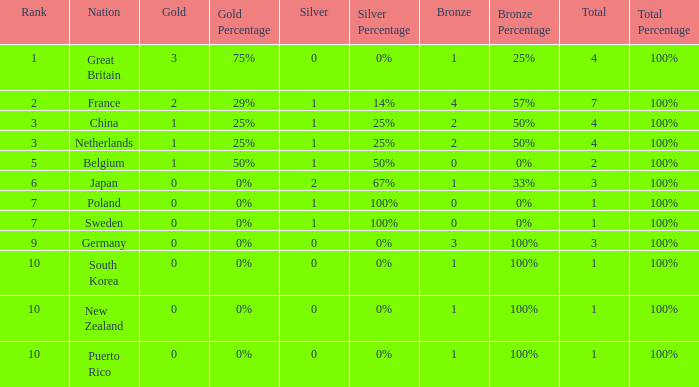What is the total where the gold is larger than 2? 1.0. 